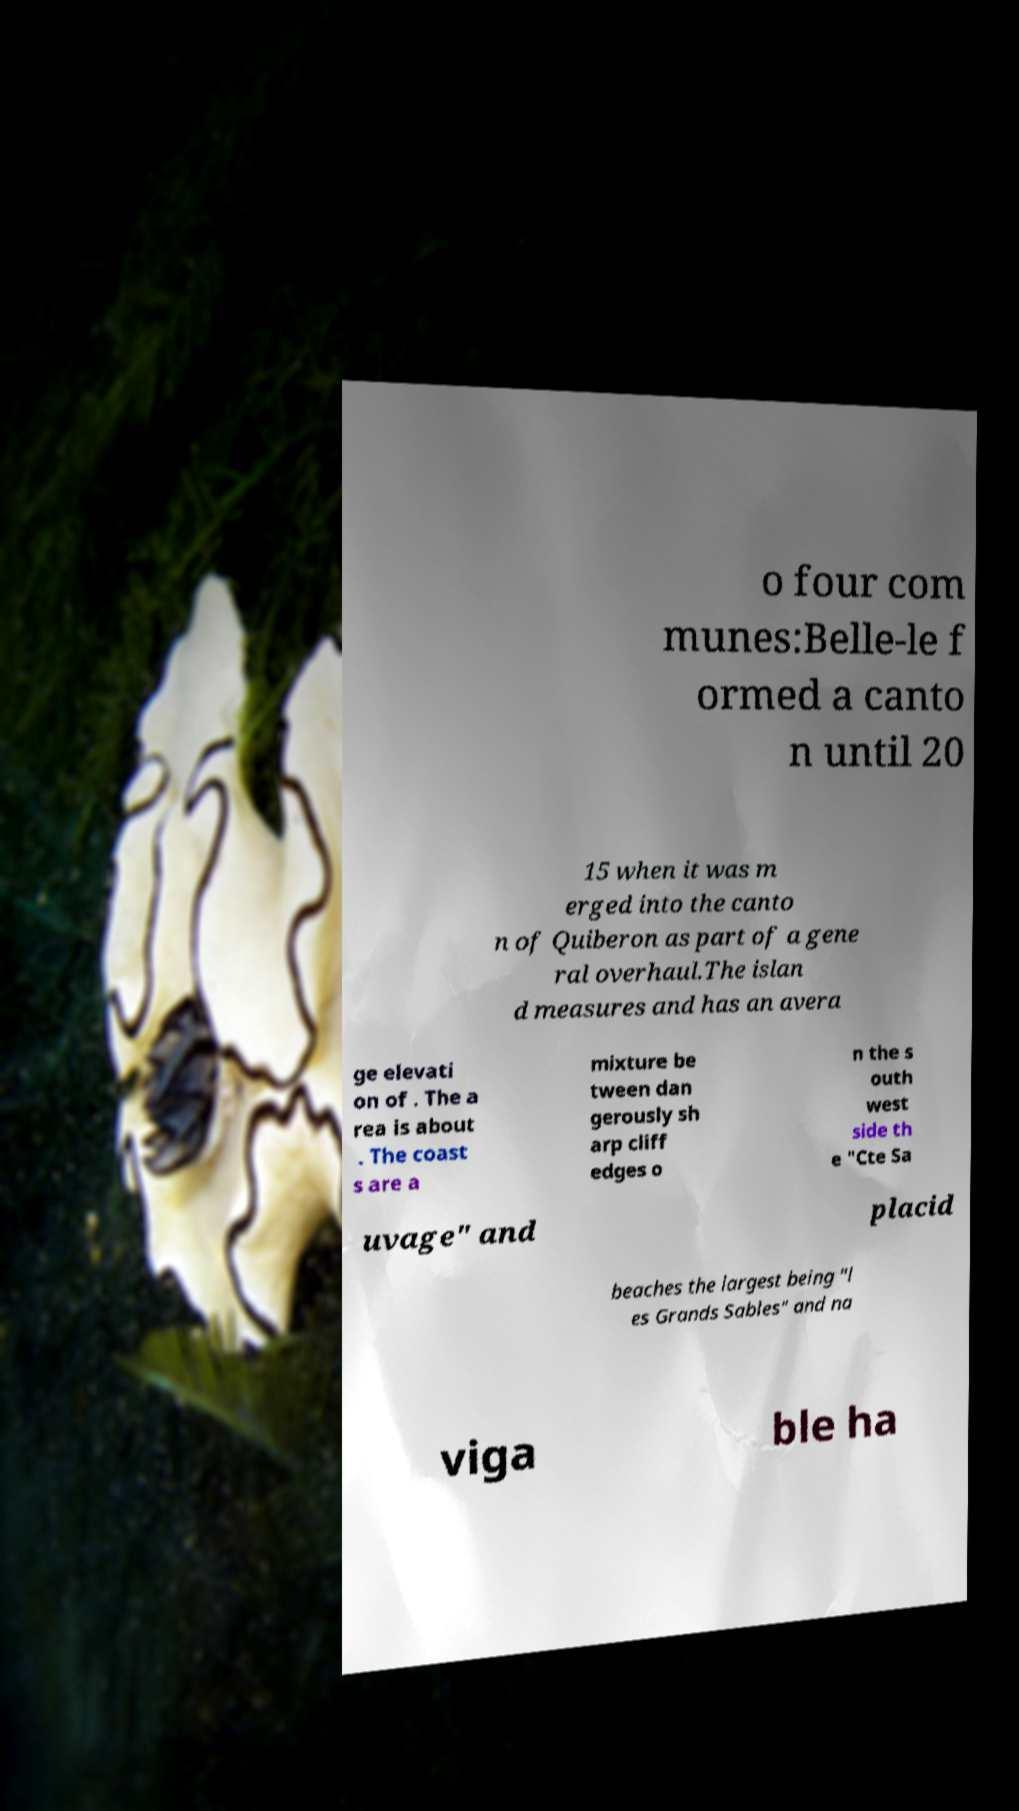What messages or text are displayed in this image? I need them in a readable, typed format. o four com munes:Belle-le f ormed a canto n until 20 15 when it was m erged into the canto n of Quiberon as part of a gene ral overhaul.The islan d measures and has an avera ge elevati on of . The a rea is about . The coast s are a mixture be tween dan gerously sh arp cliff edges o n the s outh west side th e "Cte Sa uvage" and placid beaches the largest being "l es Grands Sables" and na viga ble ha 